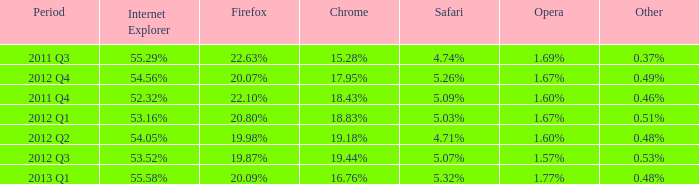What opera has 19.87% as the firefox? 1.57%. 